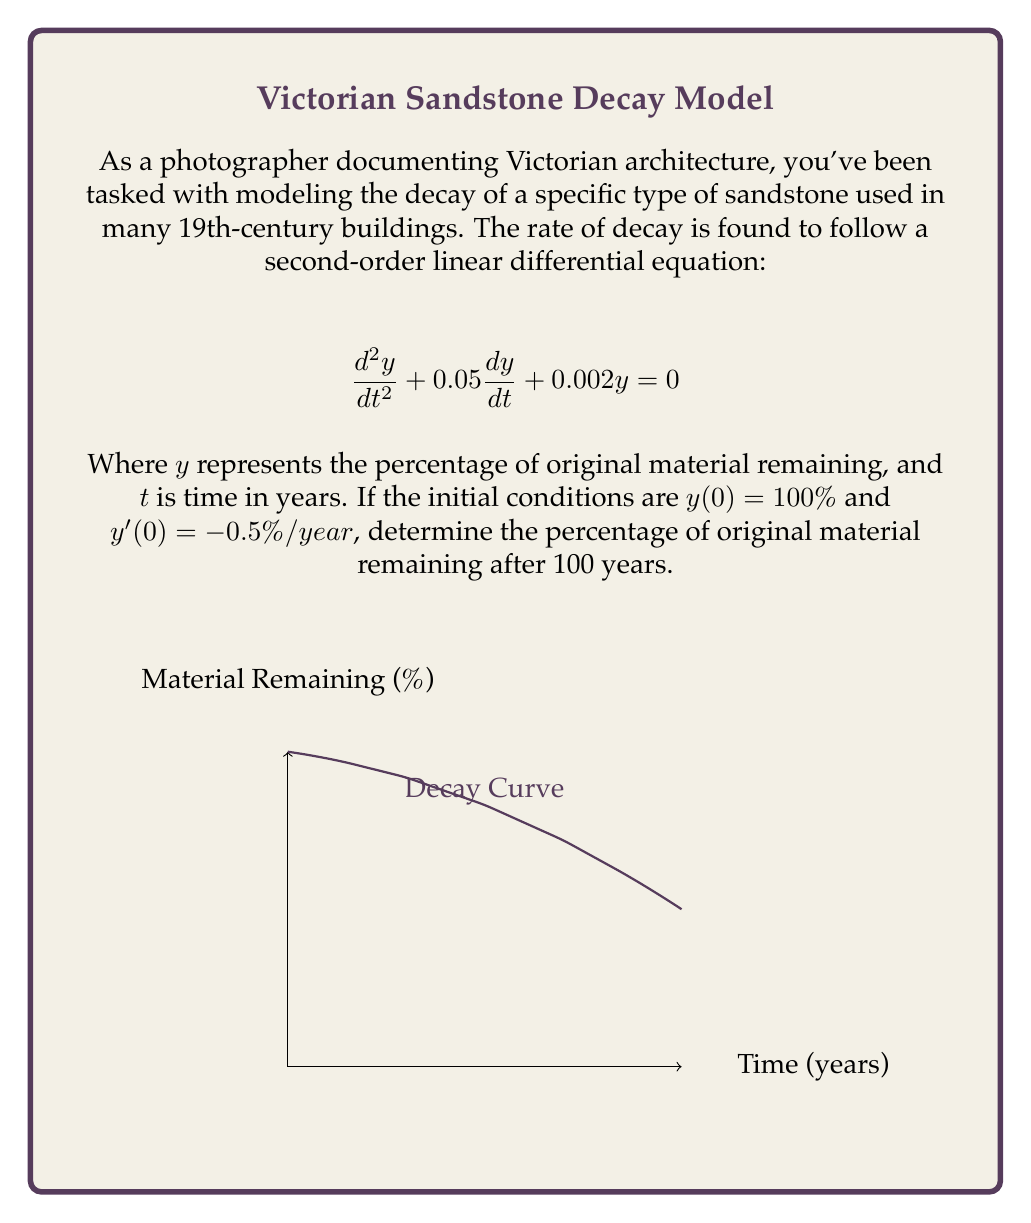Teach me how to tackle this problem. To solve this problem, we follow these steps:

1) The characteristic equation for this differential equation is:
   $$r^2 + 0.05r + 0.002 = 0$$

2) Solving this quadratic equation:
   $$r = \frac{-0.05 \pm \sqrt{0.05^2 - 4(0.002)}}{2} = -0.025 \pm 0.0435i$$

3) The general solution is therefore:
   $$y = e^{-0.025t}(A\cos(0.0435t) + B\sin(0.0435t))$$

4) Using the initial condition $y(0) = 100$:
   $$100 = A$$

5) The derivative of the general solution is:
   $$y' = -0.025e^{-0.025t}(A\cos(0.0435t) + B\sin(0.0435t)) + e^{-0.025t}(-0.0435A\sin(0.0435t) + 0.0435B\cos(0.0435t))$$

6) Using the initial condition $y'(0) = -0.5$:
   $$-0.5 = -0.025A + 0.0435B$$
   $$-0.5 = -2.5 + 0.0435B$$
   $$B = 45.98$$

7) Therefore, the particular solution is:
   $$y = 100e^{-0.025t}(\cos(0.0435t) + 0.4598\sin(0.0435t))$$

8) After 100 years, $t = 100$:
   $$y(100) = 100e^{-2.5}(\cos(4.35) + 0.4598\sin(4.35)) \approx 8.2076$$
Answer: $8.21\%$ 